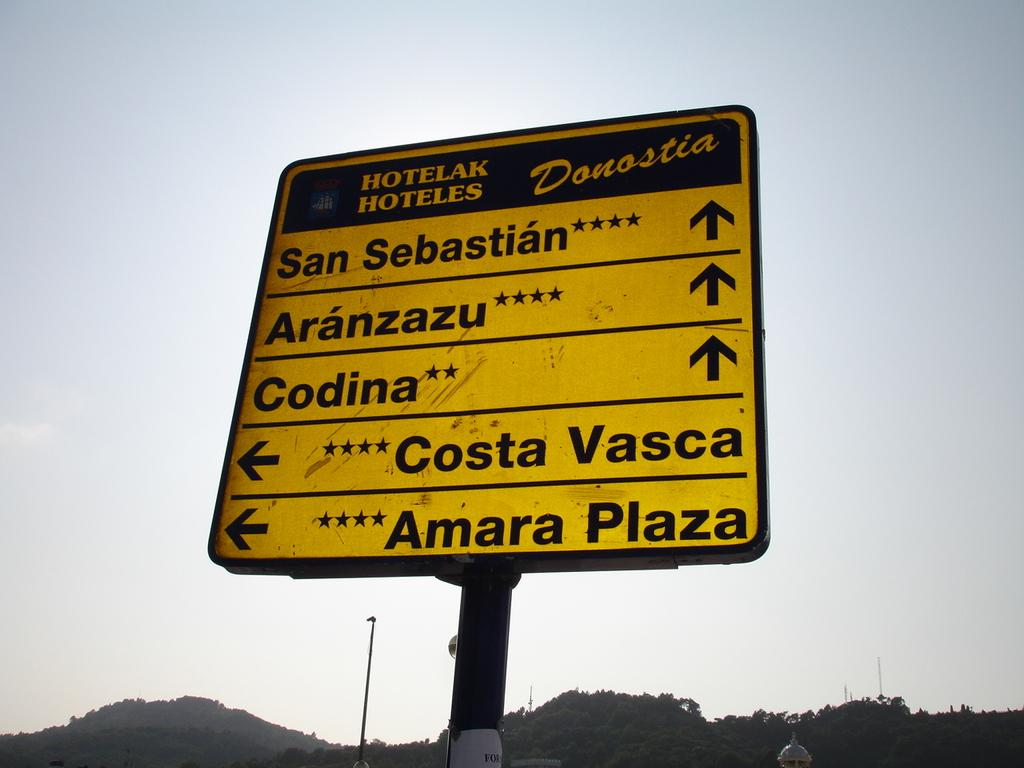<image>
Present a compact description of the photo's key features. Sign with places to go and hotels located in the city 